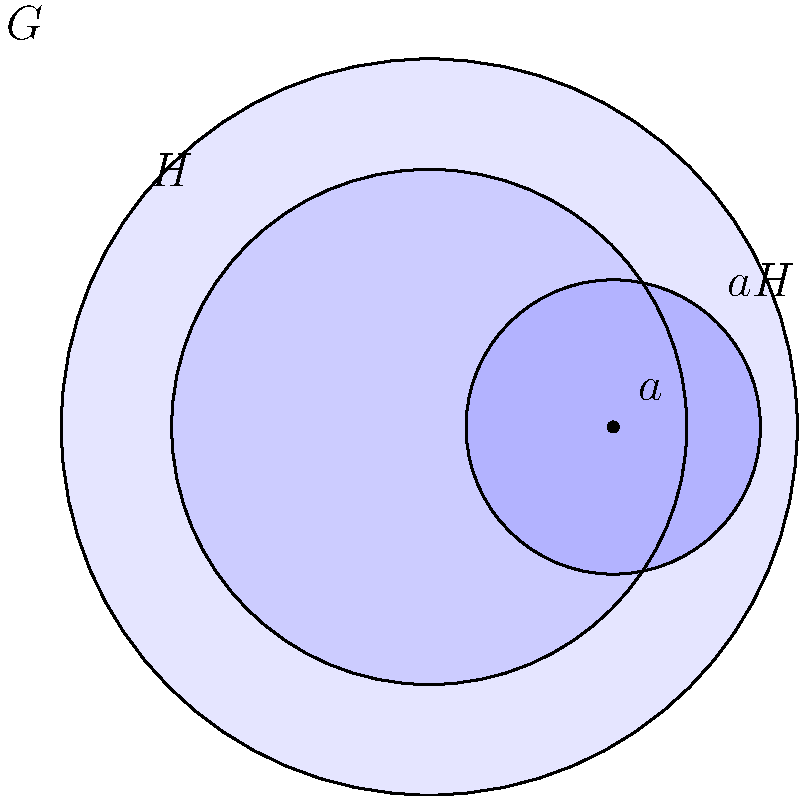In the Venn diagram representation of a group $G$ with subgroup $H$ and coset $aH$, what does the region exclusively within $aH$ (not overlapping with $H$) represent in terms of group theory concepts? To answer this question, let's break down the concept step-by-step:

1. The largest circle represents the entire group $G$.
2. The middle circle represents the subgroup $H$ of $G$.
3. The smallest circle represents the left coset $aH$ for some element $a \in G$.

4. The region exclusively within $aH$ (not overlapping with $H$) represents elements that are in $aH$ but not in $H$. This can be understood as follows:

   a) For any element $x$ in this region, $x \in aH$ but $x \notin H$.
   b) By definition of a left coset, $x = ah$ for some $h \in H$.
   c) If $a \notin H$, then $ah \notin H$ for all $h \in H$.

5. This region essentially shows the "shift" or "translation" of the subgroup $H$ by the element $a$.

6. In group theory terms, this region represents the elements that demonstrate the difference between $H$ and its coset $aH$ when $a \notin H$.

7. The existence of this non-overlapping region also indicates that $a$ is not in $H$, because if $a \in H$, then $aH = H$ and there would be no separate region for $aH$.

8. This visualization helps in understanding the concept of distinct cosets and how they partition the group $G$.

Therefore, the region exclusively within $aH$ represents the elements that are in the coset $aH$ but not in the subgroup $H$, showcasing the "shift" of $H$ by $a$ when $a \notin H$.
Answer: Elements in $aH \setminus H$ 